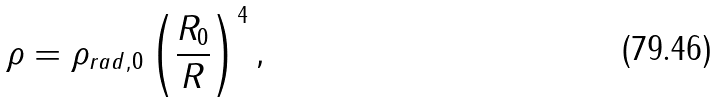<formula> <loc_0><loc_0><loc_500><loc_500>\rho = \rho _ { r a d , 0 } \left ( \frac { R _ { 0 } } { R } \right ) ^ { 4 } ,</formula> 